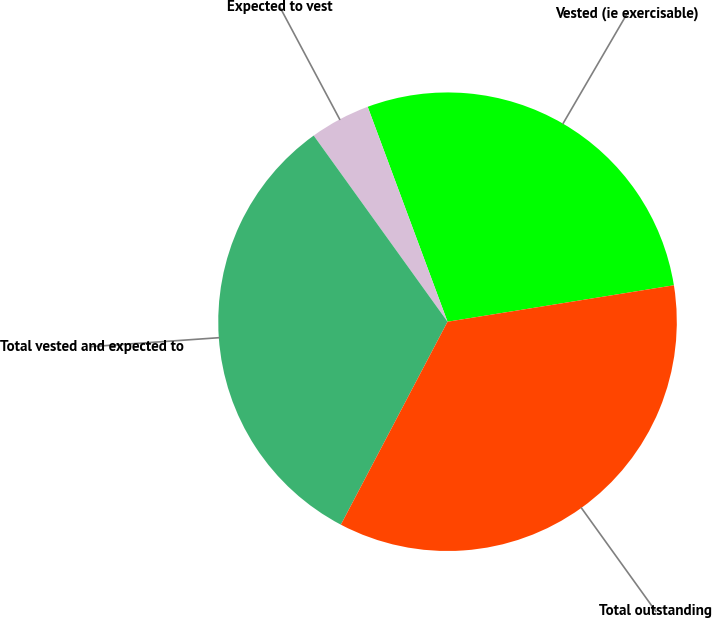<chart> <loc_0><loc_0><loc_500><loc_500><pie_chart><fcel>Vested (ie exercisable)<fcel>Expected to vest<fcel>Total vested and expected to<fcel>Total outstanding<nl><fcel>28.12%<fcel>4.26%<fcel>32.38%<fcel>35.24%<nl></chart> 